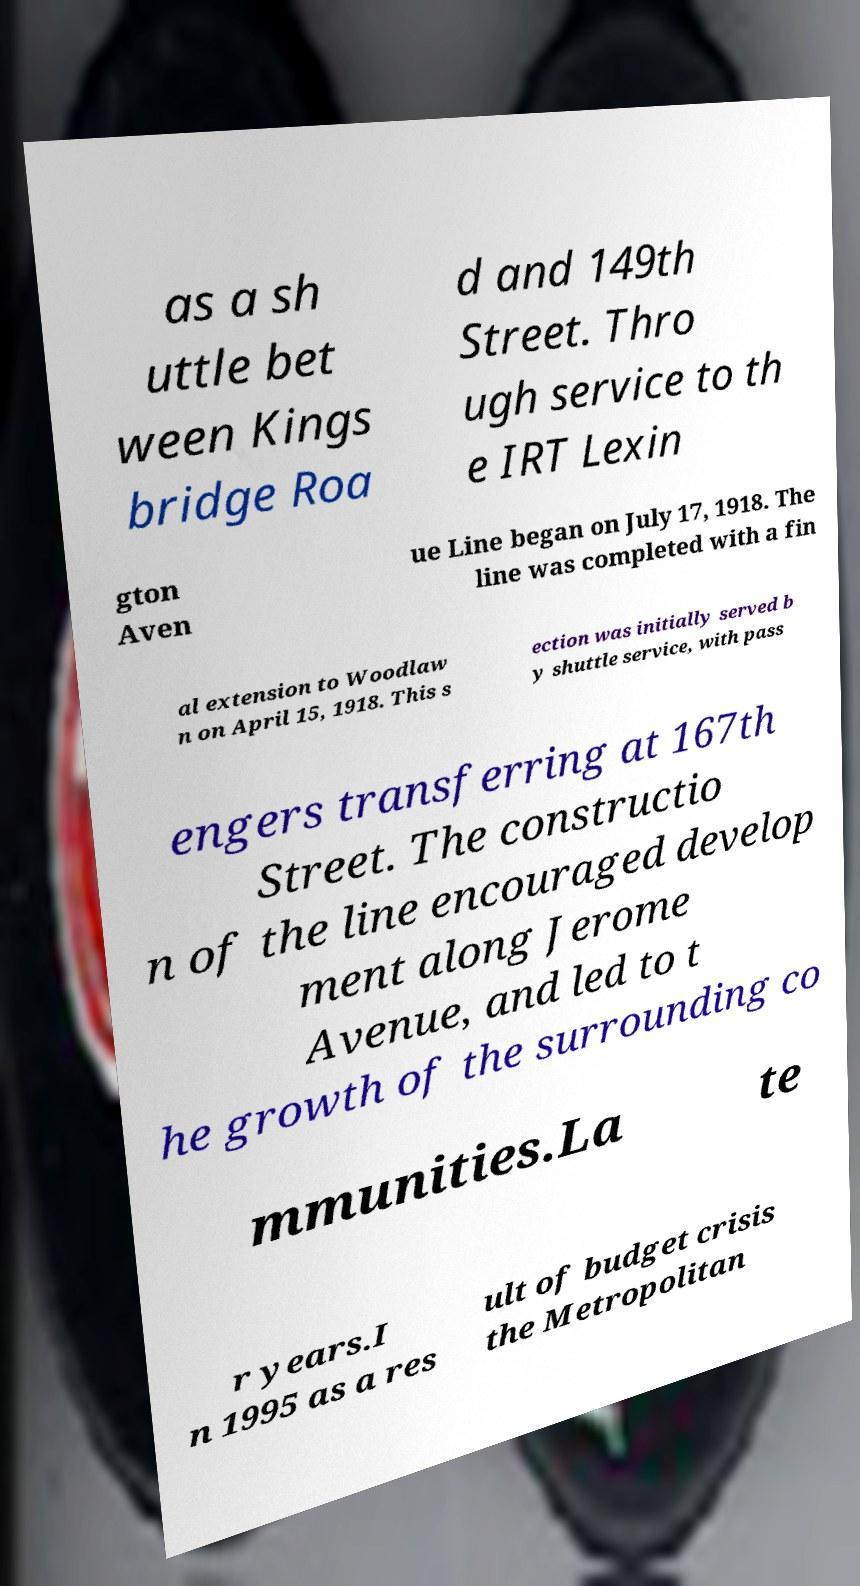Could you extract and type out the text from this image? as a sh uttle bet ween Kings bridge Roa d and 149th Street. Thro ugh service to th e IRT Lexin gton Aven ue Line began on July 17, 1918. The line was completed with a fin al extension to Woodlaw n on April 15, 1918. This s ection was initially served b y shuttle service, with pass engers transferring at 167th Street. The constructio n of the line encouraged develop ment along Jerome Avenue, and led to t he growth of the surrounding co mmunities.La te r years.I n 1995 as a res ult of budget crisis the Metropolitan 